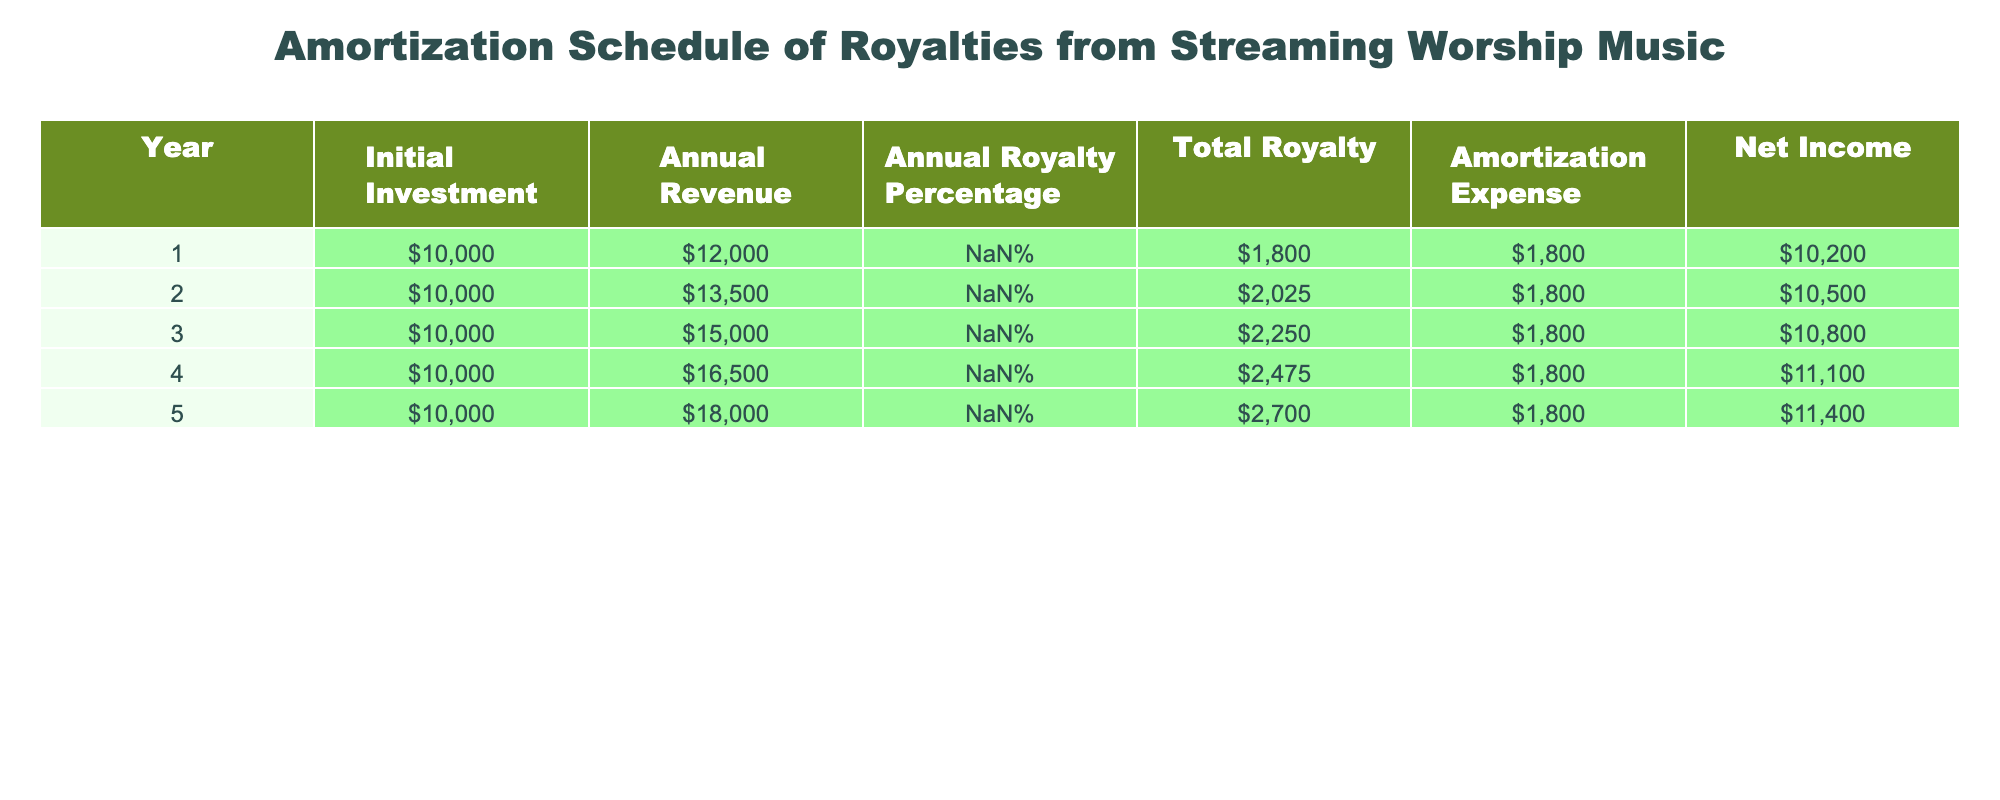What was the total royalty received in Year 3? In Year 3, the 'Total Royalty' column shows the value, which is reported as 2250.
Answer: 2250 What is the annual net income in Year 5? The 'Net Income' for Year 5 is clearly shown in the final column as 11400.
Answer: 11400 In which year did the total royalty reach its highest value? Looking at the 'Total Royalty' column across all years, Year 5 has the highest value of 2700.
Answer: Year 5 What is the average annual revenue over the five years? To find the average, sum the annual revenues: 12000 + 13500 + 15000 + 16500 + 18000 = 90000. Then divide by 5, resulting in an average of 18000.
Answer: 18000 Does the amortization expense remain constant across all years? Observing the 'Amortization Expense' column, it consistently shows 1800 for all five years.
Answer: Yes Which year had the lowest annual revenue? By checking the 'Annual Revenue' column, Year 1 has the lowest value at 12000.
Answer: Year 1 What is the total royalty received over all five years? To calculate the total, sum the 'Total Royalty' values: 1800 + 2025 + 2250 + 2475 + 2700 = 11150.
Answer: 11150 How much did the annual revenue increase from Year 1 to Year 4? The annual revenue in Year 1 is 12000, and in Year 4 it's 16500. Thus, the increase is 16500 - 12000 = 4500.
Answer: 4500 What can you say about the trend in net income over the five years? Observing the 'Net Income' column, it increases each year: 10200, 10500, 10800, 11100, 11400 reflects a positive trend.
Answer: It increases consistently 